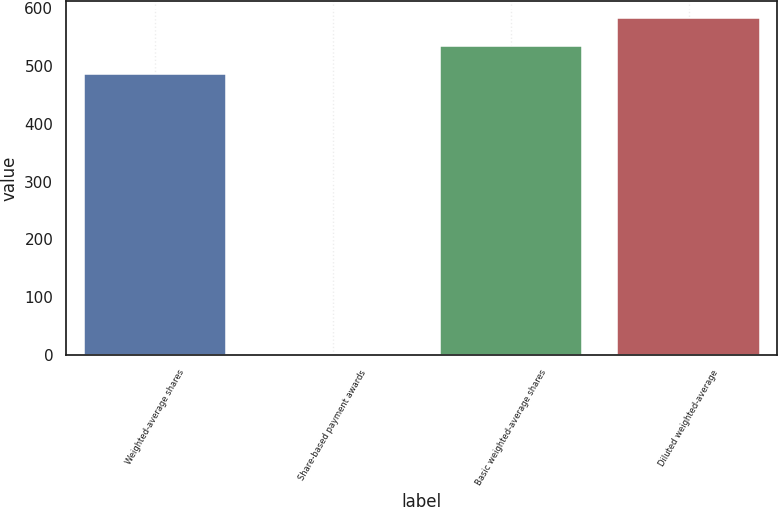<chart> <loc_0><loc_0><loc_500><loc_500><bar_chart><fcel>Weighted-average shares<fcel>Share-based payment awards<fcel>Basic weighted-average shares<fcel>Diluted weighted-average<nl><fcel>485.7<fcel>1<fcel>534.4<fcel>583.1<nl></chart> 